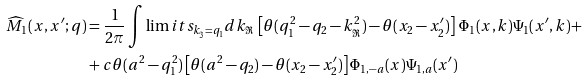Convert formula to latex. <formula><loc_0><loc_0><loc_500><loc_500>\widehat { M } _ { 1 } ( x , x ^ { \prime } ; q ) & = \frac { 1 } { 2 \pi } \int \lim i t s _ { k _ { \Im } = q _ { 1 } } d k _ { \Re } \, \left [ \theta ( q _ { 1 } ^ { 2 } - q _ { 2 } - k _ { \Re } ^ { 2 } ) - \theta ( x _ { 2 } - x _ { 2 } ^ { \prime } ) \right ] \, \Phi _ { 1 } ( x , k ) \Psi _ { 1 } ( x ^ { \prime } , k ) + \\ & + c \theta ( a ^ { 2 } - q _ { 1 } ^ { 2 } ) \left [ \theta ( a ^ { 2 } - q _ { 2 } ) - \theta ( x _ { 2 } - x _ { 2 } ^ { \prime } ) \right ] \Phi _ { 1 , - a } ( x ) \Psi _ { 1 , a } ( x ^ { \prime } )</formula> 